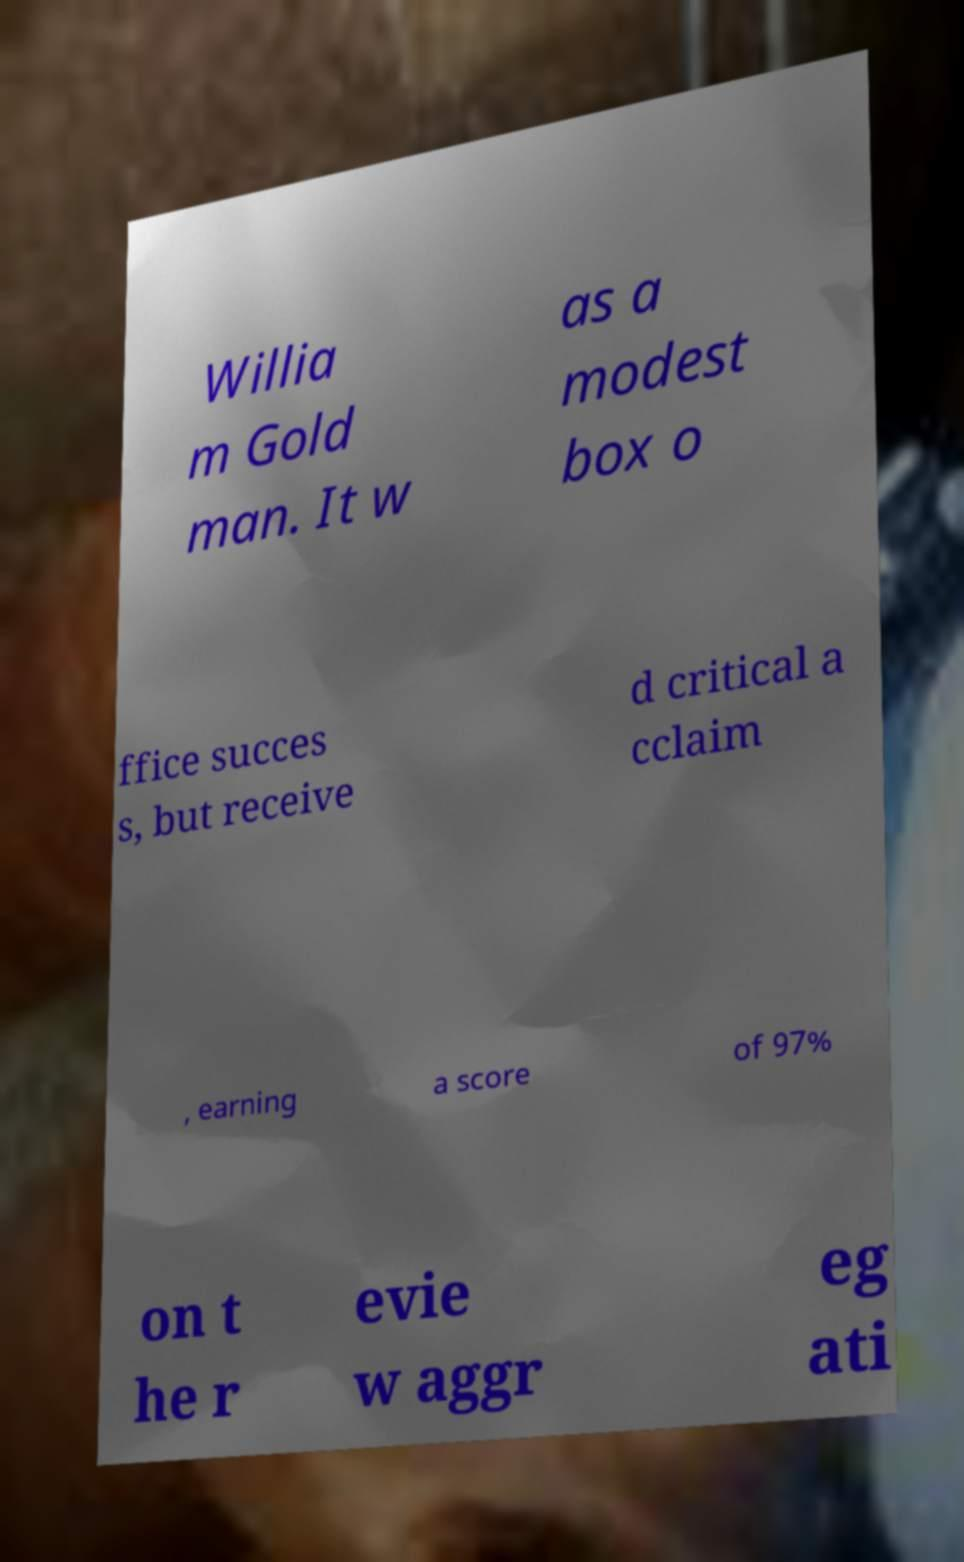There's text embedded in this image that I need extracted. Can you transcribe it verbatim? Willia m Gold man. It w as a modest box o ffice succes s, but receive d critical a cclaim , earning a score of 97% on t he r evie w aggr eg ati 